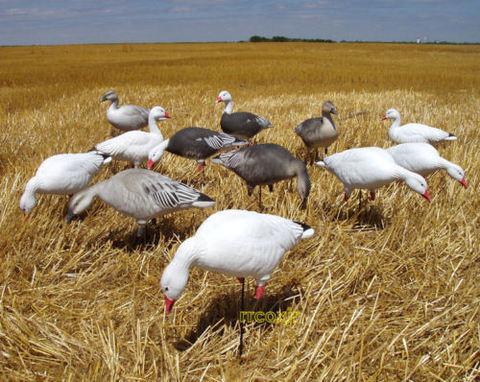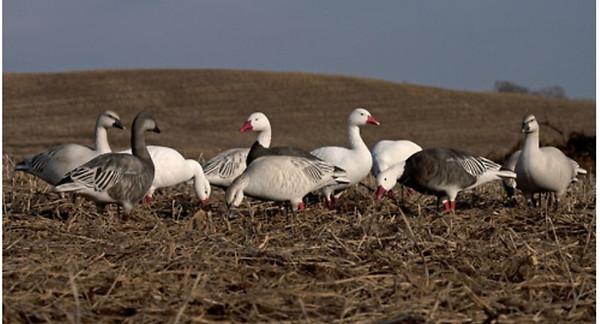The first image is the image on the left, the second image is the image on the right. Assess this claim about the two images: "Has atleast one picture with 6 or less ducks.". Correct or not? Answer yes or no. No. The first image is the image on the left, the second image is the image on the right. For the images shown, is this caption "Duck decoys, including white duck forms with heads bent down, are in a field of yellow straw in one image." true? Answer yes or no. Yes. 